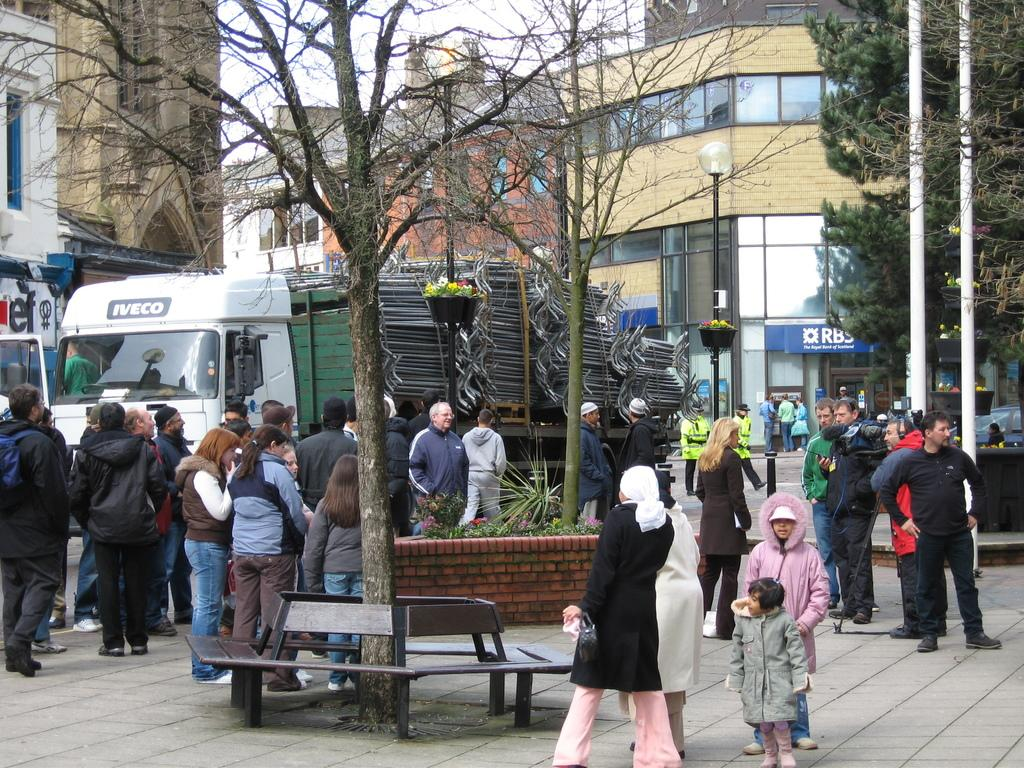What type of structures can be seen in the image? There are buildings in the image. What other natural elements are present in the image? There are trees in the image. What are the vertical objects in the image used for? There are poles in the image, which are likely used for support or signage. Can you describe the people in the image? There are people in the image, but their specific actions or activities are not mentioned in the facts. What type of seating is available in the image? There are benches in the image. What type of transportation can be seen in the image? There are vehicles in the image. What type of elbow is visible in the image? There is no elbow visible in the image. What is the selection of fruits available in the image? The facts provided do not mention any fruits in the image. 